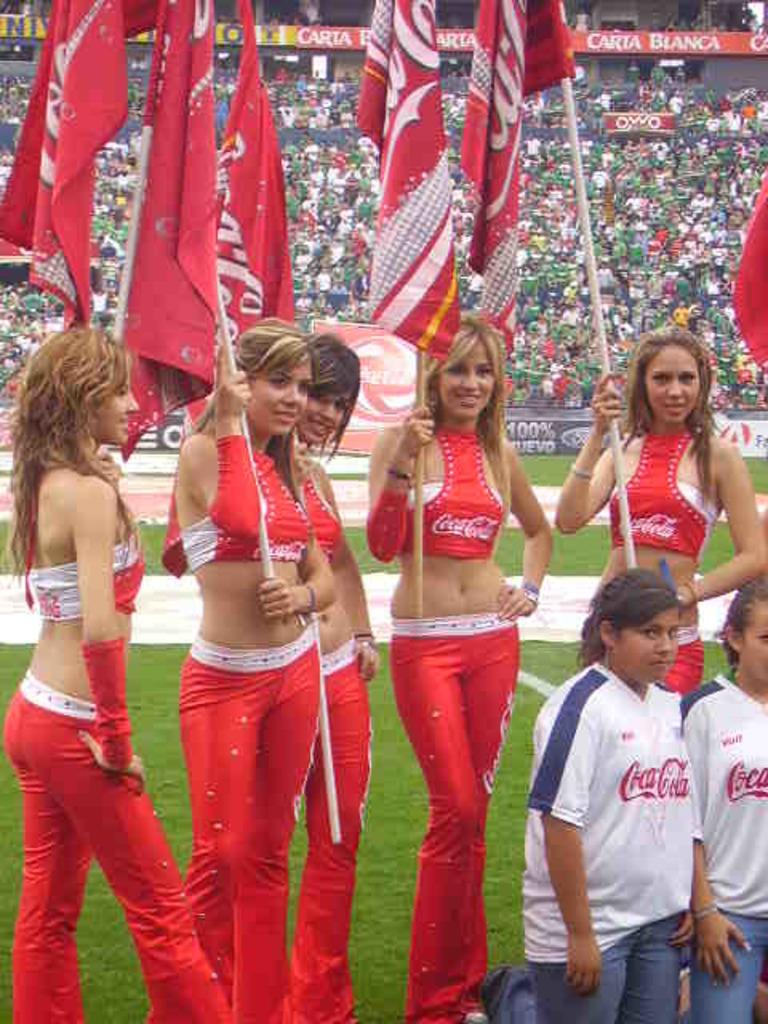<image>
Write a terse but informative summary of the picture. Five young women are each holding red Coca-Cola flags 